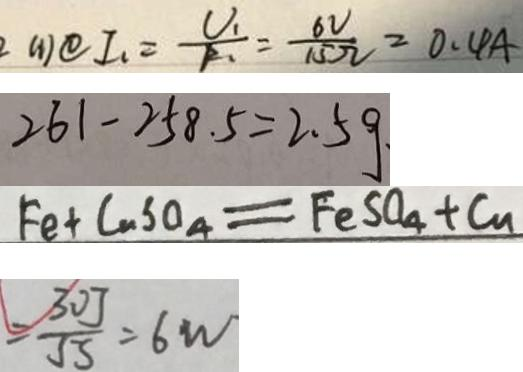Convert formula to latex. <formula><loc_0><loc_0><loc_500><loc_500>( 1 ) \textcircled { 1 } I _ { 1 } = \frac { U _ { 1 } } { R _ { 1 } } = \frac { 6 V } { 1 5 \Omega } = 0 . 4 A 
 2 6 1 - 2 5 8 . 5 = 2 . 5 g . 
 F e + C u S O _ { 4 } = F e S O _ { 4 } + C u 
 = \frac { 3 0 J } { 5 S } = 6 w</formula> 